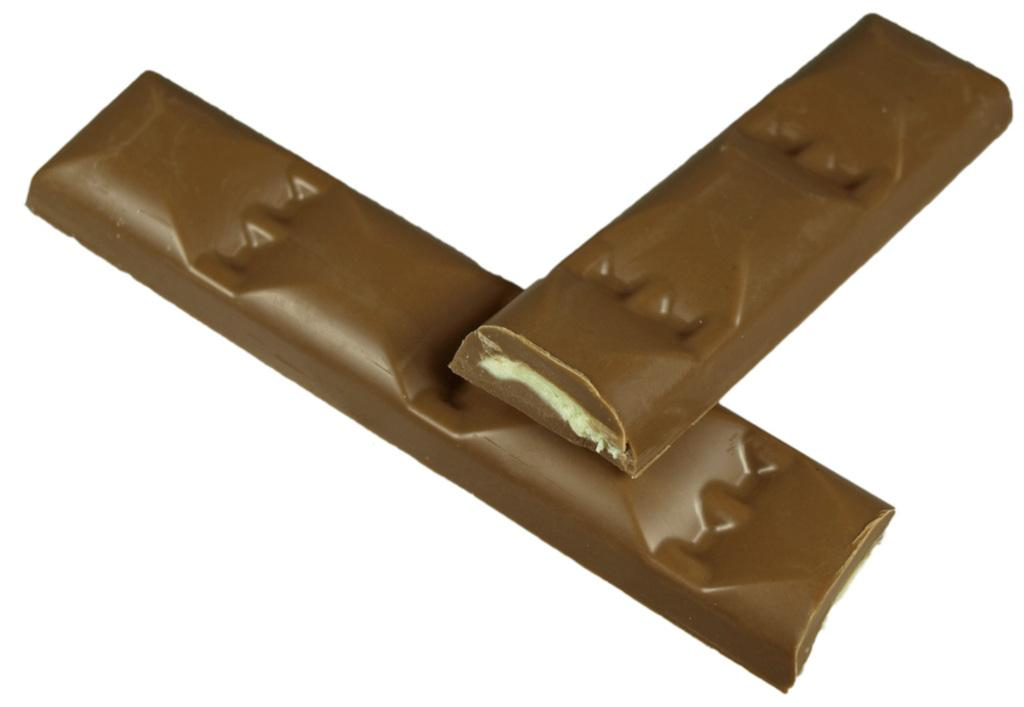What type of food items are present in the image? There are two chocolate bars in the image. What color is the background of the image? The background of the image is white. Can you describe the setting of the image? The image may have been taken in a room, as there is no indication of an outdoor setting. What type of doll is being used in the battle scene depicted in the image? There is no doll or battle scene present in the image; it features two chocolate bars against a white background. 